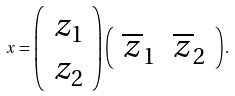<formula> <loc_0><loc_0><loc_500><loc_500>x = \left ( \begin{array} { c } z _ { 1 } \\ z _ { 2 } \end{array} \right ) \left ( \begin{array} { c c } \overline { z } _ { 1 } & \overline { z } _ { 2 } \end{array} \right ) .</formula> 